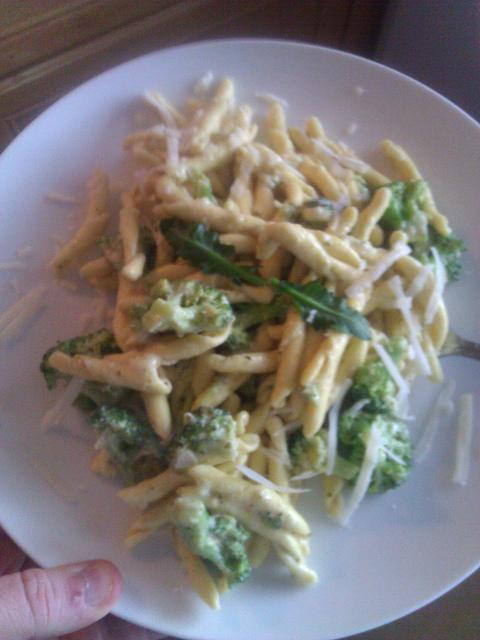Why is the leaf on top? Please explain your reasoning. garnish. It could also act as a b. 